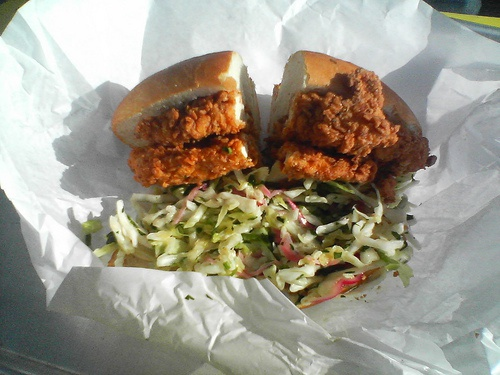Describe the objects in this image and their specific colors. I can see sandwich in black, maroon, and brown tones and sandwich in black, maroon, brown, and gray tones in this image. 